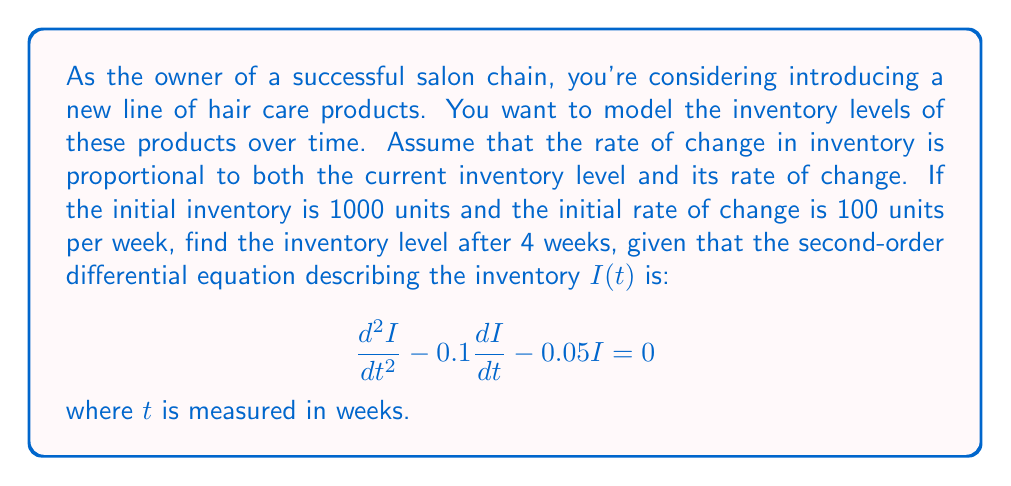Could you help me with this problem? To solve this problem, we need to follow these steps:

1) First, we need to find the general solution to the given differential equation. The characteristic equation is:

   $$r^2 - 0.1r - 0.05 = 0$$

2) Solving this quadratic equation:
   $$r = \frac{0.1 \pm \sqrt{0.01 + 0.2}}{2} = \frac{0.1 \pm \sqrt{0.21}}{2}$$
   $$r_1 = \frac{0.1 + \sqrt{0.21}}{2} \approx 0.3291$$
   $$r_2 = \frac{0.1 - \sqrt{0.21}}{2} \approx -0.1291$$

3) The general solution is therefore:
   $$I(t) = C_1e^{0.3291t} + C_2e^{-0.1291t}$$

4) Now we use the initial conditions to find $C_1$ and $C_2$:
   At $t=0$, $I(0) = 1000$ and $I'(0) = 100$

5) From $I(0) = 1000$:
   $$1000 = C_1 + C_2$$

6) From $I'(0) = 100$:
   $$100 = 0.3291C_1 - 0.1291C_2$$

7) Solving these equations simultaneously:
   $$C_1 \approx 741.94, C_2 \approx 258.06$$

8) Therefore, the particular solution is:
   $$I(t) = 741.94e^{0.3291t} + 258.06e^{-0.1291t}$$

9) To find the inventory after 4 weeks, we substitute $t=4$:
   $$I(4) = 741.94e^{0.3291(4)} + 258.06e^{-0.1291(4)}$$
   $$\approx 741.94(3.7409) + 258.06(0.5944)$$
   $$\approx 2776.53 + 153.39$$
   $$\approx 2929.92$$
Answer: The inventory level after 4 weeks will be approximately 2930 units. 